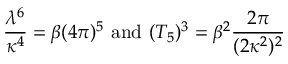<formula> <loc_0><loc_0><loc_500><loc_500>\frac { \lambda ^ { 6 } } { \kappa ^ { 4 } } = \beta ( 4 \pi ) ^ { 5 } a n d ( T _ { 5 } ) ^ { 3 } = \beta ^ { 2 } \frac { 2 \pi } { ( 2 \kappa ^ { 2 } ) ^ { 2 } }</formula> 